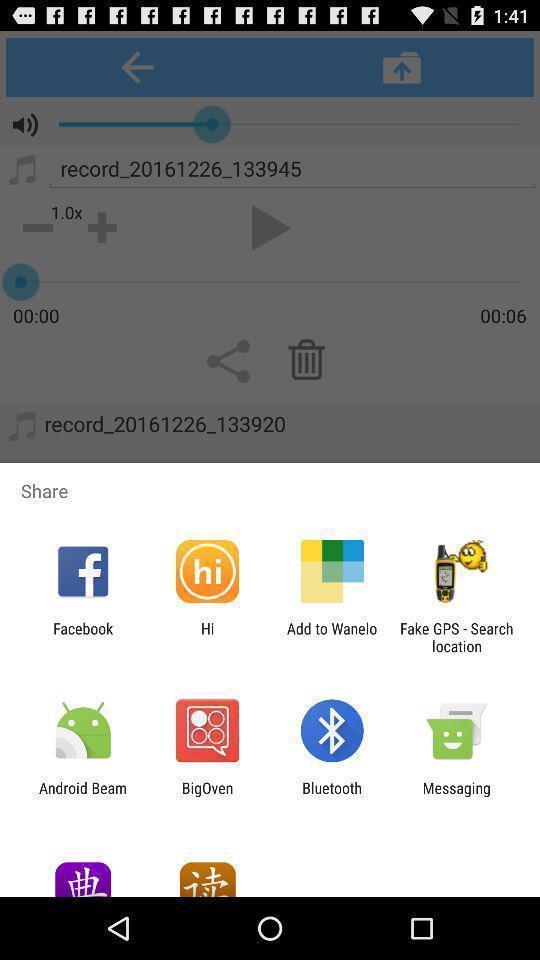What details can you identify in this image? Popup showing different apps to share. 